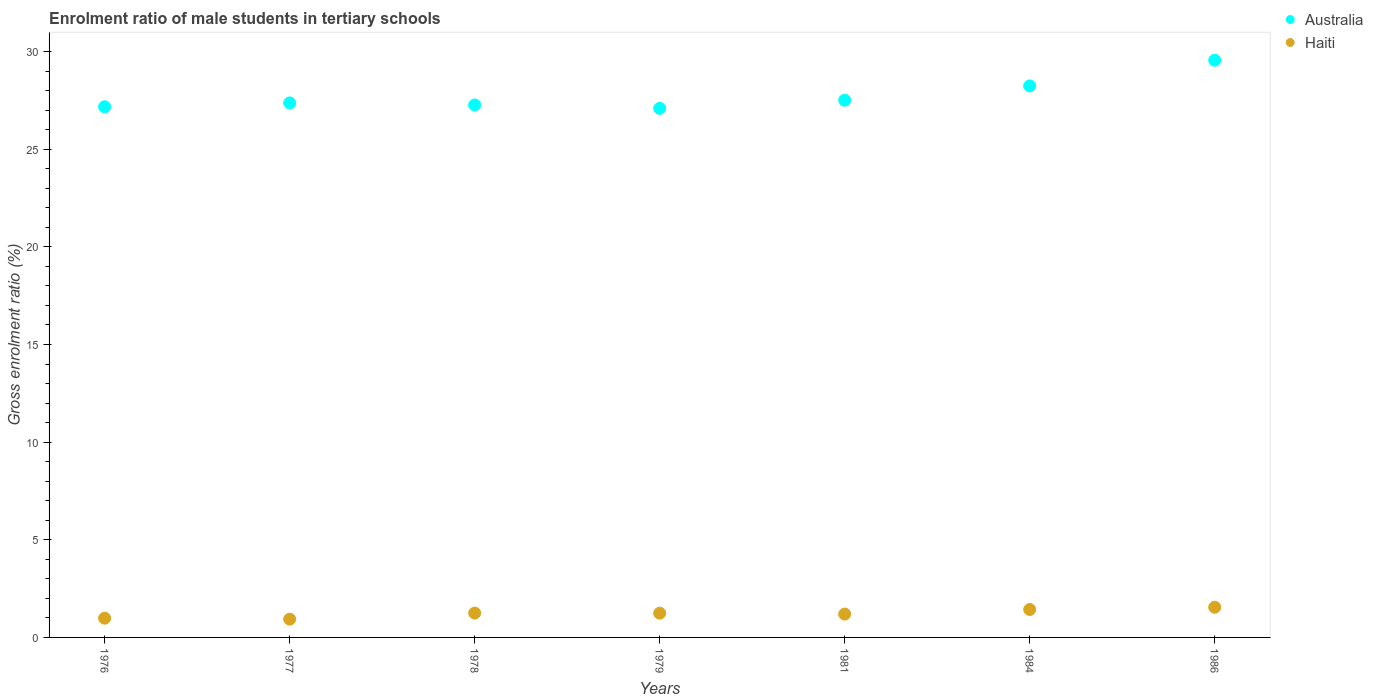What is the enrolment ratio of male students in tertiary schools in Australia in 1986?
Your response must be concise. 29.56. Across all years, what is the maximum enrolment ratio of male students in tertiary schools in Haiti?
Ensure brevity in your answer.  1.54. Across all years, what is the minimum enrolment ratio of male students in tertiary schools in Haiti?
Make the answer very short. 0.94. What is the total enrolment ratio of male students in tertiary schools in Australia in the graph?
Ensure brevity in your answer.  194.2. What is the difference between the enrolment ratio of male students in tertiary schools in Haiti in 1979 and that in 1986?
Give a very brief answer. -0.3. What is the difference between the enrolment ratio of male students in tertiary schools in Australia in 1986 and the enrolment ratio of male students in tertiary schools in Haiti in 1976?
Your response must be concise. 28.57. What is the average enrolment ratio of male students in tertiary schools in Haiti per year?
Keep it short and to the point. 1.23. In the year 1978, what is the difference between the enrolment ratio of male students in tertiary schools in Australia and enrolment ratio of male students in tertiary schools in Haiti?
Offer a terse response. 26.02. In how many years, is the enrolment ratio of male students in tertiary schools in Australia greater than 20 %?
Offer a terse response. 7. What is the ratio of the enrolment ratio of male students in tertiary schools in Haiti in 1978 to that in 1979?
Offer a very short reply. 1. Is the enrolment ratio of male students in tertiary schools in Haiti in 1984 less than that in 1986?
Your response must be concise. Yes. Is the difference between the enrolment ratio of male students in tertiary schools in Australia in 1976 and 1984 greater than the difference between the enrolment ratio of male students in tertiary schools in Haiti in 1976 and 1984?
Your answer should be compact. No. What is the difference between the highest and the second highest enrolment ratio of male students in tertiary schools in Australia?
Give a very brief answer. 1.32. What is the difference between the highest and the lowest enrolment ratio of male students in tertiary schools in Australia?
Offer a very short reply. 2.47. In how many years, is the enrolment ratio of male students in tertiary schools in Haiti greater than the average enrolment ratio of male students in tertiary schools in Haiti taken over all years?
Offer a very short reply. 4. Is the sum of the enrolment ratio of male students in tertiary schools in Australia in 1976 and 1978 greater than the maximum enrolment ratio of male students in tertiary schools in Haiti across all years?
Your answer should be very brief. Yes. Does the enrolment ratio of male students in tertiary schools in Haiti monotonically increase over the years?
Ensure brevity in your answer.  No. Is the enrolment ratio of male students in tertiary schools in Australia strictly greater than the enrolment ratio of male students in tertiary schools in Haiti over the years?
Ensure brevity in your answer.  Yes. How many dotlines are there?
Keep it short and to the point. 2. How many years are there in the graph?
Keep it short and to the point. 7. What is the difference between two consecutive major ticks on the Y-axis?
Provide a short and direct response. 5. Are the values on the major ticks of Y-axis written in scientific E-notation?
Your answer should be very brief. No. Does the graph contain any zero values?
Provide a succinct answer. No. Does the graph contain grids?
Keep it short and to the point. No. How many legend labels are there?
Offer a very short reply. 2. What is the title of the graph?
Offer a very short reply. Enrolment ratio of male students in tertiary schools. Does "Cyprus" appear as one of the legend labels in the graph?
Your response must be concise. No. What is the label or title of the X-axis?
Your response must be concise. Years. What is the Gross enrolment ratio (%) in Australia in 1976?
Make the answer very short. 27.17. What is the Gross enrolment ratio (%) in Haiti in 1976?
Give a very brief answer. 0.99. What is the Gross enrolment ratio (%) in Australia in 1977?
Give a very brief answer. 27.37. What is the Gross enrolment ratio (%) of Haiti in 1977?
Make the answer very short. 0.94. What is the Gross enrolment ratio (%) in Australia in 1978?
Make the answer very short. 27.26. What is the Gross enrolment ratio (%) in Haiti in 1978?
Offer a terse response. 1.25. What is the Gross enrolment ratio (%) of Australia in 1979?
Give a very brief answer. 27.09. What is the Gross enrolment ratio (%) of Haiti in 1979?
Keep it short and to the point. 1.24. What is the Gross enrolment ratio (%) of Australia in 1981?
Give a very brief answer. 27.51. What is the Gross enrolment ratio (%) in Haiti in 1981?
Give a very brief answer. 1.19. What is the Gross enrolment ratio (%) in Australia in 1984?
Your answer should be very brief. 28.24. What is the Gross enrolment ratio (%) of Haiti in 1984?
Provide a short and direct response. 1.43. What is the Gross enrolment ratio (%) in Australia in 1986?
Give a very brief answer. 29.56. What is the Gross enrolment ratio (%) in Haiti in 1986?
Provide a succinct answer. 1.54. Across all years, what is the maximum Gross enrolment ratio (%) of Australia?
Your response must be concise. 29.56. Across all years, what is the maximum Gross enrolment ratio (%) of Haiti?
Your response must be concise. 1.54. Across all years, what is the minimum Gross enrolment ratio (%) in Australia?
Ensure brevity in your answer.  27.09. Across all years, what is the minimum Gross enrolment ratio (%) of Haiti?
Ensure brevity in your answer.  0.94. What is the total Gross enrolment ratio (%) of Australia in the graph?
Provide a short and direct response. 194.2. What is the total Gross enrolment ratio (%) of Haiti in the graph?
Your answer should be very brief. 8.58. What is the difference between the Gross enrolment ratio (%) in Australia in 1976 and that in 1977?
Provide a short and direct response. -0.2. What is the difference between the Gross enrolment ratio (%) of Haiti in 1976 and that in 1977?
Give a very brief answer. 0.05. What is the difference between the Gross enrolment ratio (%) of Australia in 1976 and that in 1978?
Ensure brevity in your answer.  -0.09. What is the difference between the Gross enrolment ratio (%) in Haiti in 1976 and that in 1978?
Your answer should be very brief. -0.26. What is the difference between the Gross enrolment ratio (%) of Australia in 1976 and that in 1979?
Provide a short and direct response. 0.08. What is the difference between the Gross enrolment ratio (%) of Haiti in 1976 and that in 1979?
Your answer should be very brief. -0.26. What is the difference between the Gross enrolment ratio (%) of Australia in 1976 and that in 1981?
Your answer should be very brief. -0.34. What is the difference between the Gross enrolment ratio (%) in Haiti in 1976 and that in 1981?
Offer a very short reply. -0.21. What is the difference between the Gross enrolment ratio (%) in Australia in 1976 and that in 1984?
Provide a succinct answer. -1.07. What is the difference between the Gross enrolment ratio (%) in Haiti in 1976 and that in 1984?
Offer a very short reply. -0.44. What is the difference between the Gross enrolment ratio (%) in Australia in 1976 and that in 1986?
Provide a short and direct response. -2.38. What is the difference between the Gross enrolment ratio (%) of Haiti in 1976 and that in 1986?
Offer a very short reply. -0.56. What is the difference between the Gross enrolment ratio (%) of Australia in 1977 and that in 1978?
Make the answer very short. 0.1. What is the difference between the Gross enrolment ratio (%) in Haiti in 1977 and that in 1978?
Offer a very short reply. -0.31. What is the difference between the Gross enrolment ratio (%) of Australia in 1977 and that in 1979?
Keep it short and to the point. 0.28. What is the difference between the Gross enrolment ratio (%) of Haiti in 1977 and that in 1979?
Keep it short and to the point. -0.31. What is the difference between the Gross enrolment ratio (%) in Australia in 1977 and that in 1981?
Provide a succinct answer. -0.14. What is the difference between the Gross enrolment ratio (%) in Haiti in 1977 and that in 1981?
Offer a very short reply. -0.26. What is the difference between the Gross enrolment ratio (%) of Australia in 1977 and that in 1984?
Ensure brevity in your answer.  -0.87. What is the difference between the Gross enrolment ratio (%) of Haiti in 1977 and that in 1984?
Your answer should be very brief. -0.49. What is the difference between the Gross enrolment ratio (%) of Australia in 1977 and that in 1986?
Offer a very short reply. -2.19. What is the difference between the Gross enrolment ratio (%) of Haiti in 1977 and that in 1986?
Your response must be concise. -0.61. What is the difference between the Gross enrolment ratio (%) in Australia in 1978 and that in 1979?
Give a very brief answer. 0.17. What is the difference between the Gross enrolment ratio (%) of Haiti in 1978 and that in 1979?
Make the answer very short. 0. What is the difference between the Gross enrolment ratio (%) in Australia in 1978 and that in 1981?
Your answer should be compact. -0.25. What is the difference between the Gross enrolment ratio (%) of Haiti in 1978 and that in 1981?
Your response must be concise. 0.05. What is the difference between the Gross enrolment ratio (%) of Australia in 1978 and that in 1984?
Keep it short and to the point. -0.97. What is the difference between the Gross enrolment ratio (%) in Haiti in 1978 and that in 1984?
Give a very brief answer. -0.18. What is the difference between the Gross enrolment ratio (%) of Australia in 1978 and that in 1986?
Ensure brevity in your answer.  -2.29. What is the difference between the Gross enrolment ratio (%) of Haiti in 1978 and that in 1986?
Offer a very short reply. -0.3. What is the difference between the Gross enrolment ratio (%) of Australia in 1979 and that in 1981?
Your response must be concise. -0.42. What is the difference between the Gross enrolment ratio (%) in Haiti in 1979 and that in 1981?
Your answer should be very brief. 0.05. What is the difference between the Gross enrolment ratio (%) of Australia in 1979 and that in 1984?
Provide a short and direct response. -1.15. What is the difference between the Gross enrolment ratio (%) of Haiti in 1979 and that in 1984?
Provide a short and direct response. -0.19. What is the difference between the Gross enrolment ratio (%) of Australia in 1979 and that in 1986?
Your response must be concise. -2.47. What is the difference between the Gross enrolment ratio (%) of Haiti in 1979 and that in 1986?
Offer a very short reply. -0.3. What is the difference between the Gross enrolment ratio (%) in Australia in 1981 and that in 1984?
Offer a very short reply. -0.73. What is the difference between the Gross enrolment ratio (%) of Haiti in 1981 and that in 1984?
Provide a short and direct response. -0.23. What is the difference between the Gross enrolment ratio (%) in Australia in 1981 and that in 1986?
Give a very brief answer. -2.05. What is the difference between the Gross enrolment ratio (%) of Haiti in 1981 and that in 1986?
Your answer should be very brief. -0.35. What is the difference between the Gross enrolment ratio (%) in Australia in 1984 and that in 1986?
Provide a succinct answer. -1.32. What is the difference between the Gross enrolment ratio (%) of Haiti in 1984 and that in 1986?
Ensure brevity in your answer.  -0.11. What is the difference between the Gross enrolment ratio (%) of Australia in 1976 and the Gross enrolment ratio (%) of Haiti in 1977?
Provide a short and direct response. 26.23. What is the difference between the Gross enrolment ratio (%) of Australia in 1976 and the Gross enrolment ratio (%) of Haiti in 1978?
Give a very brief answer. 25.92. What is the difference between the Gross enrolment ratio (%) of Australia in 1976 and the Gross enrolment ratio (%) of Haiti in 1979?
Keep it short and to the point. 25.93. What is the difference between the Gross enrolment ratio (%) of Australia in 1976 and the Gross enrolment ratio (%) of Haiti in 1981?
Make the answer very short. 25.98. What is the difference between the Gross enrolment ratio (%) of Australia in 1976 and the Gross enrolment ratio (%) of Haiti in 1984?
Offer a very short reply. 25.74. What is the difference between the Gross enrolment ratio (%) in Australia in 1976 and the Gross enrolment ratio (%) in Haiti in 1986?
Provide a succinct answer. 25.63. What is the difference between the Gross enrolment ratio (%) in Australia in 1977 and the Gross enrolment ratio (%) in Haiti in 1978?
Ensure brevity in your answer.  26.12. What is the difference between the Gross enrolment ratio (%) of Australia in 1977 and the Gross enrolment ratio (%) of Haiti in 1979?
Keep it short and to the point. 26.13. What is the difference between the Gross enrolment ratio (%) of Australia in 1977 and the Gross enrolment ratio (%) of Haiti in 1981?
Offer a terse response. 26.17. What is the difference between the Gross enrolment ratio (%) of Australia in 1977 and the Gross enrolment ratio (%) of Haiti in 1984?
Keep it short and to the point. 25.94. What is the difference between the Gross enrolment ratio (%) in Australia in 1977 and the Gross enrolment ratio (%) in Haiti in 1986?
Give a very brief answer. 25.82. What is the difference between the Gross enrolment ratio (%) of Australia in 1978 and the Gross enrolment ratio (%) of Haiti in 1979?
Provide a short and direct response. 26.02. What is the difference between the Gross enrolment ratio (%) of Australia in 1978 and the Gross enrolment ratio (%) of Haiti in 1981?
Provide a short and direct response. 26.07. What is the difference between the Gross enrolment ratio (%) in Australia in 1978 and the Gross enrolment ratio (%) in Haiti in 1984?
Provide a short and direct response. 25.83. What is the difference between the Gross enrolment ratio (%) of Australia in 1978 and the Gross enrolment ratio (%) of Haiti in 1986?
Your answer should be compact. 25.72. What is the difference between the Gross enrolment ratio (%) of Australia in 1979 and the Gross enrolment ratio (%) of Haiti in 1981?
Your response must be concise. 25.89. What is the difference between the Gross enrolment ratio (%) of Australia in 1979 and the Gross enrolment ratio (%) of Haiti in 1984?
Make the answer very short. 25.66. What is the difference between the Gross enrolment ratio (%) in Australia in 1979 and the Gross enrolment ratio (%) in Haiti in 1986?
Your response must be concise. 25.54. What is the difference between the Gross enrolment ratio (%) in Australia in 1981 and the Gross enrolment ratio (%) in Haiti in 1984?
Give a very brief answer. 26.08. What is the difference between the Gross enrolment ratio (%) in Australia in 1981 and the Gross enrolment ratio (%) in Haiti in 1986?
Your response must be concise. 25.96. What is the difference between the Gross enrolment ratio (%) of Australia in 1984 and the Gross enrolment ratio (%) of Haiti in 1986?
Ensure brevity in your answer.  26.69. What is the average Gross enrolment ratio (%) in Australia per year?
Keep it short and to the point. 27.74. What is the average Gross enrolment ratio (%) in Haiti per year?
Provide a short and direct response. 1.23. In the year 1976, what is the difference between the Gross enrolment ratio (%) of Australia and Gross enrolment ratio (%) of Haiti?
Your answer should be very brief. 26.19. In the year 1977, what is the difference between the Gross enrolment ratio (%) in Australia and Gross enrolment ratio (%) in Haiti?
Give a very brief answer. 26.43. In the year 1978, what is the difference between the Gross enrolment ratio (%) of Australia and Gross enrolment ratio (%) of Haiti?
Offer a terse response. 26.02. In the year 1979, what is the difference between the Gross enrolment ratio (%) of Australia and Gross enrolment ratio (%) of Haiti?
Provide a short and direct response. 25.85. In the year 1981, what is the difference between the Gross enrolment ratio (%) of Australia and Gross enrolment ratio (%) of Haiti?
Ensure brevity in your answer.  26.31. In the year 1984, what is the difference between the Gross enrolment ratio (%) in Australia and Gross enrolment ratio (%) in Haiti?
Your answer should be compact. 26.81. In the year 1986, what is the difference between the Gross enrolment ratio (%) in Australia and Gross enrolment ratio (%) in Haiti?
Provide a succinct answer. 28.01. What is the ratio of the Gross enrolment ratio (%) in Australia in 1976 to that in 1977?
Provide a succinct answer. 0.99. What is the ratio of the Gross enrolment ratio (%) in Haiti in 1976 to that in 1977?
Make the answer very short. 1.05. What is the ratio of the Gross enrolment ratio (%) in Australia in 1976 to that in 1978?
Ensure brevity in your answer.  1. What is the ratio of the Gross enrolment ratio (%) in Haiti in 1976 to that in 1978?
Your response must be concise. 0.79. What is the ratio of the Gross enrolment ratio (%) in Haiti in 1976 to that in 1979?
Offer a terse response. 0.79. What is the ratio of the Gross enrolment ratio (%) in Australia in 1976 to that in 1981?
Ensure brevity in your answer.  0.99. What is the ratio of the Gross enrolment ratio (%) in Haiti in 1976 to that in 1981?
Give a very brief answer. 0.82. What is the ratio of the Gross enrolment ratio (%) of Australia in 1976 to that in 1984?
Offer a terse response. 0.96. What is the ratio of the Gross enrolment ratio (%) of Haiti in 1976 to that in 1984?
Offer a terse response. 0.69. What is the ratio of the Gross enrolment ratio (%) in Australia in 1976 to that in 1986?
Keep it short and to the point. 0.92. What is the ratio of the Gross enrolment ratio (%) in Haiti in 1976 to that in 1986?
Provide a succinct answer. 0.64. What is the ratio of the Gross enrolment ratio (%) in Haiti in 1977 to that in 1978?
Offer a terse response. 0.75. What is the ratio of the Gross enrolment ratio (%) of Australia in 1977 to that in 1979?
Your response must be concise. 1.01. What is the ratio of the Gross enrolment ratio (%) of Haiti in 1977 to that in 1979?
Offer a terse response. 0.75. What is the ratio of the Gross enrolment ratio (%) of Haiti in 1977 to that in 1981?
Keep it short and to the point. 0.78. What is the ratio of the Gross enrolment ratio (%) of Australia in 1977 to that in 1984?
Provide a short and direct response. 0.97. What is the ratio of the Gross enrolment ratio (%) in Haiti in 1977 to that in 1984?
Offer a terse response. 0.65. What is the ratio of the Gross enrolment ratio (%) in Australia in 1977 to that in 1986?
Your response must be concise. 0.93. What is the ratio of the Gross enrolment ratio (%) in Haiti in 1977 to that in 1986?
Your answer should be compact. 0.61. What is the ratio of the Gross enrolment ratio (%) in Australia in 1978 to that in 1979?
Provide a succinct answer. 1.01. What is the ratio of the Gross enrolment ratio (%) in Haiti in 1978 to that in 1979?
Your answer should be very brief. 1. What is the ratio of the Gross enrolment ratio (%) in Haiti in 1978 to that in 1981?
Provide a short and direct response. 1.04. What is the ratio of the Gross enrolment ratio (%) in Australia in 1978 to that in 1984?
Your answer should be very brief. 0.97. What is the ratio of the Gross enrolment ratio (%) of Haiti in 1978 to that in 1984?
Your answer should be very brief. 0.87. What is the ratio of the Gross enrolment ratio (%) in Australia in 1978 to that in 1986?
Offer a terse response. 0.92. What is the ratio of the Gross enrolment ratio (%) of Haiti in 1978 to that in 1986?
Your answer should be compact. 0.81. What is the ratio of the Gross enrolment ratio (%) of Australia in 1979 to that in 1981?
Keep it short and to the point. 0.98. What is the ratio of the Gross enrolment ratio (%) in Haiti in 1979 to that in 1981?
Offer a very short reply. 1.04. What is the ratio of the Gross enrolment ratio (%) in Australia in 1979 to that in 1984?
Keep it short and to the point. 0.96. What is the ratio of the Gross enrolment ratio (%) of Haiti in 1979 to that in 1984?
Offer a terse response. 0.87. What is the ratio of the Gross enrolment ratio (%) of Australia in 1979 to that in 1986?
Keep it short and to the point. 0.92. What is the ratio of the Gross enrolment ratio (%) of Haiti in 1979 to that in 1986?
Offer a very short reply. 0.8. What is the ratio of the Gross enrolment ratio (%) in Australia in 1981 to that in 1984?
Your answer should be very brief. 0.97. What is the ratio of the Gross enrolment ratio (%) of Haiti in 1981 to that in 1984?
Your answer should be compact. 0.84. What is the ratio of the Gross enrolment ratio (%) in Australia in 1981 to that in 1986?
Provide a succinct answer. 0.93. What is the ratio of the Gross enrolment ratio (%) of Haiti in 1981 to that in 1986?
Make the answer very short. 0.77. What is the ratio of the Gross enrolment ratio (%) in Australia in 1984 to that in 1986?
Provide a short and direct response. 0.96. What is the ratio of the Gross enrolment ratio (%) of Haiti in 1984 to that in 1986?
Your answer should be very brief. 0.93. What is the difference between the highest and the second highest Gross enrolment ratio (%) in Australia?
Give a very brief answer. 1.32. What is the difference between the highest and the second highest Gross enrolment ratio (%) in Haiti?
Offer a very short reply. 0.11. What is the difference between the highest and the lowest Gross enrolment ratio (%) in Australia?
Offer a very short reply. 2.47. What is the difference between the highest and the lowest Gross enrolment ratio (%) in Haiti?
Give a very brief answer. 0.61. 